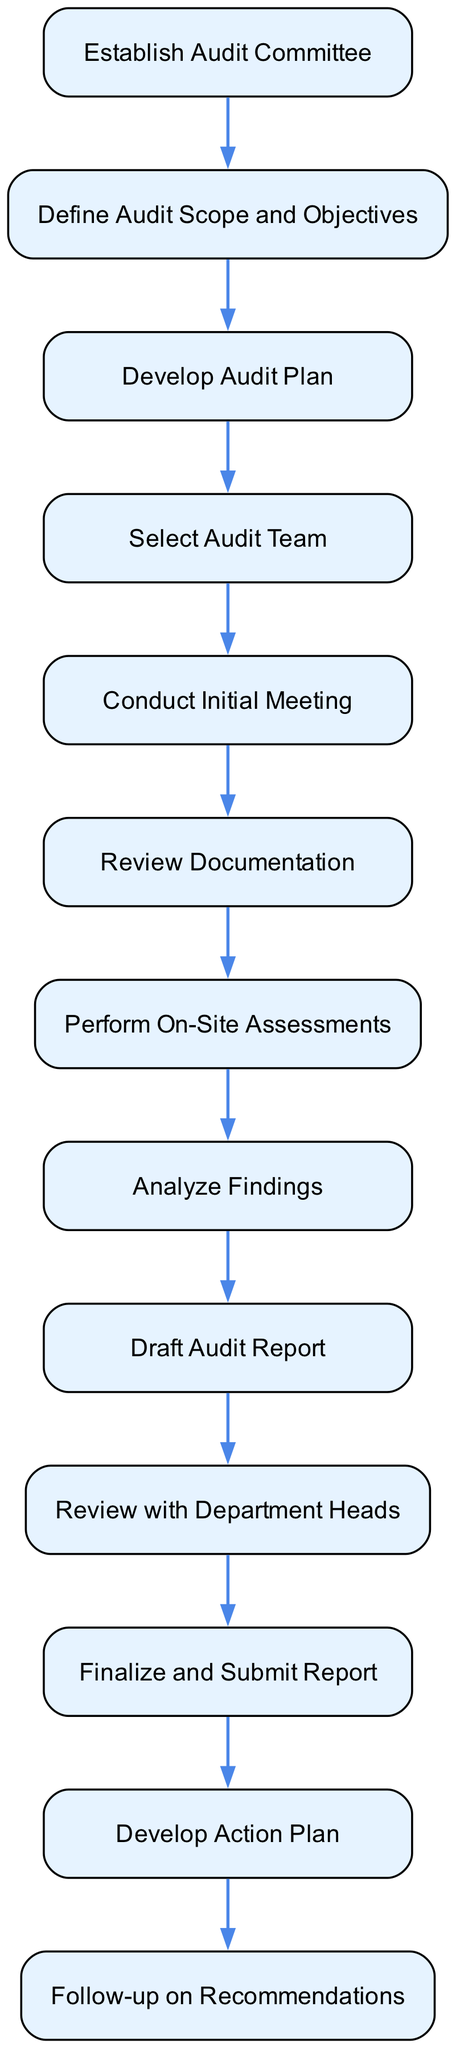What is the first step in the audit protocol? The first step in the audit protocol is to establish the audit committee, as indicated by the first node in the flowchart.
Answer: Establish Audit Committee How many nodes are in the diagram? The diagram contains a total of thirteen nodes, which are each represented by individual steps in the internal audit protocol.
Answer: 13 What is the last step after the finalizing and submitting the report? After finalizing and submitting the report, the next step is to develop an action plan, showing the progression from reporting to planning actions based on the audit findings.
Answer: Develop Action Plan Which node follows the "Conduct Initial Meeting"? The node that follows "Conduct Initial Meeting" is "Review Documentation," indicating the sequential nature of the audit process where documentation review comes after the initial meeting.
Answer: Review Documentation What is the purpose of the "Analyze Findings" step? The purpose of the "Analyze Findings" step is to assess the results obtained from assessments to identify compliance levels and issues, guiding the subsequent drafting of the audit report.
Answer: Assess results How many edges connect the nodes? There are twelve edges connecting the nodes, signifying the flow from one step to the next throughout the entire audit process.
Answer: 12 What happens after the "Draft Audit Report"? After drafting the audit report, the next step is to review it with department heads, which involves sharing results before finalizing the report.
Answer: Review with Department Heads Which node is linked directly to the "Develop Action Plan"? The node that is directly linked to "Develop Action Plan" is "Finalize and Submit Report," showing that planning actions is contingent on the completion and acceptance of the report.
Answer: Finalize and Submit Report What is the second node in the sequence? The second node in the sequence is "Define Audit Scope and Objectives," which lays foundational goals and parameters for the audit process.
Answer: Define Audit Scope and Objectives 